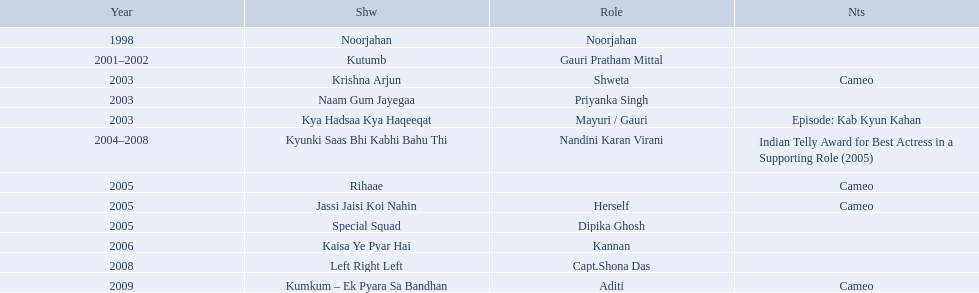What shows was gauri tejwani in? Noorjahan, Kutumb, Krishna Arjun, Naam Gum Jayegaa, Kya Hadsaa Kya Haqeeqat, Kyunki Saas Bhi Kabhi Bahu Thi, Rihaae, Jassi Jaisi Koi Nahin, Special Squad, Kaisa Ye Pyar Hai, Left Right Left, Kumkum – Ek Pyara Sa Bandhan. What were the 2005 shows? Rihaae, Jassi Jaisi Koi Nahin, Special Squad. Which were cameos? Rihaae, Jassi Jaisi Koi Nahin. Of which of these it was not rihaee? Jassi Jaisi Koi Nahin. What role  was played for the latest show Cameo. Who played the last cameo before ? Jassi Jaisi Koi Nahin. What shows did gauri pradhan tejwani star in? Noorjahan, Kutumb, Krishna Arjun, Naam Gum Jayegaa, Kya Hadsaa Kya Haqeeqat, Kyunki Saas Bhi Kabhi Bahu Thi, Rihaae, Jassi Jaisi Koi Nahin, Special Squad, Kaisa Ye Pyar Hai, Left Right Left, Kumkum – Ek Pyara Sa Bandhan. Of these, which were cameos? Krishna Arjun, Rihaae, Jassi Jaisi Koi Nahin, Kumkum – Ek Pyara Sa Bandhan. Of these, in which did she play the role of herself? Jassi Jaisi Koi Nahin. How many shows are there? Noorjahan, Kutumb, Krishna Arjun, Naam Gum Jayegaa, Kya Hadsaa Kya Haqeeqat, Kyunki Saas Bhi Kabhi Bahu Thi, Rihaae, Jassi Jaisi Koi Nahin, Special Squad, Kaisa Ye Pyar Hai, Left Right Left, Kumkum – Ek Pyara Sa Bandhan. How many shows did she make a cameo appearance? Krishna Arjun, Rihaae, Jassi Jaisi Koi Nahin, Kumkum – Ek Pyara Sa Bandhan. Of those, how many did she play herself? Jassi Jaisi Koi Nahin. On what shows did gauri pradhan tejwani appear after 2000? Kutumb, Krishna Arjun, Naam Gum Jayegaa, Kya Hadsaa Kya Haqeeqat, Kyunki Saas Bhi Kabhi Bahu Thi, Rihaae, Jassi Jaisi Koi Nahin, Special Squad, Kaisa Ye Pyar Hai, Left Right Left, Kumkum – Ek Pyara Sa Bandhan. In which of them was is a cameo appearance? Krishna Arjun, Rihaae, Jassi Jaisi Koi Nahin, Kumkum – Ek Pyara Sa Bandhan. Of these which one did she play the role of herself? Jassi Jaisi Koi Nahin. What are all of the shows? Noorjahan, Kutumb, Krishna Arjun, Naam Gum Jayegaa, Kya Hadsaa Kya Haqeeqat, Kyunki Saas Bhi Kabhi Bahu Thi, Rihaae, Jassi Jaisi Koi Nahin, Special Squad, Kaisa Ye Pyar Hai, Left Right Left, Kumkum – Ek Pyara Sa Bandhan. When were they in production? 1998, 2001–2002, 2003, 2003, 2003, 2004–2008, 2005, 2005, 2005, 2006, 2008, 2009. And which show was he on for the longest time? Kyunki Saas Bhi Kabhi Bahu Thi. Can you give me this table as a dict? {'header': ['Year', 'Shw', 'Role', 'Nts'], 'rows': [['1998', 'Noorjahan', 'Noorjahan', ''], ['2001–2002', 'Kutumb', 'Gauri Pratham Mittal', ''], ['2003', 'Krishna Arjun', 'Shweta', 'Cameo'], ['2003', 'Naam Gum Jayegaa', 'Priyanka Singh', ''], ['2003', 'Kya Hadsaa Kya Haqeeqat', 'Mayuri / Gauri', 'Episode: Kab Kyun Kahan'], ['2004–2008', 'Kyunki Saas Bhi Kabhi Bahu Thi', 'Nandini Karan Virani', 'Indian Telly Award for Best Actress in a Supporting Role (2005)'], ['2005', 'Rihaae', '', 'Cameo'], ['2005', 'Jassi Jaisi Koi Nahin', 'Herself', 'Cameo'], ['2005', 'Special Squad', 'Dipika Ghosh', ''], ['2006', 'Kaisa Ye Pyar Hai', 'Kannan', ''], ['2008', 'Left Right Left', 'Capt.Shona Das', ''], ['2009', 'Kumkum – Ek Pyara Sa Bandhan', 'Aditi', 'Cameo']]} What shows has gauri pradhan tejwani been in? Noorjahan, Kutumb, Krishna Arjun, Naam Gum Jayegaa, Kya Hadsaa Kya Haqeeqat, Kyunki Saas Bhi Kabhi Bahu Thi, Rihaae, Jassi Jaisi Koi Nahin, Special Squad, Kaisa Ye Pyar Hai, Left Right Left, Kumkum – Ek Pyara Sa Bandhan. Of these shows, which one lasted for more than a year? Kutumb, Kyunki Saas Bhi Kabhi Bahu Thi. Which of these lasted the longest? Kyunki Saas Bhi Kabhi Bahu Thi. 